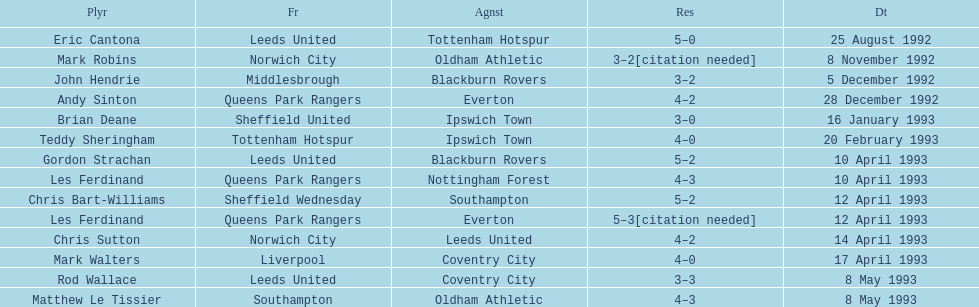Southampton played on may 8th, 1993, who was their opponent? Oldham Athletic. 